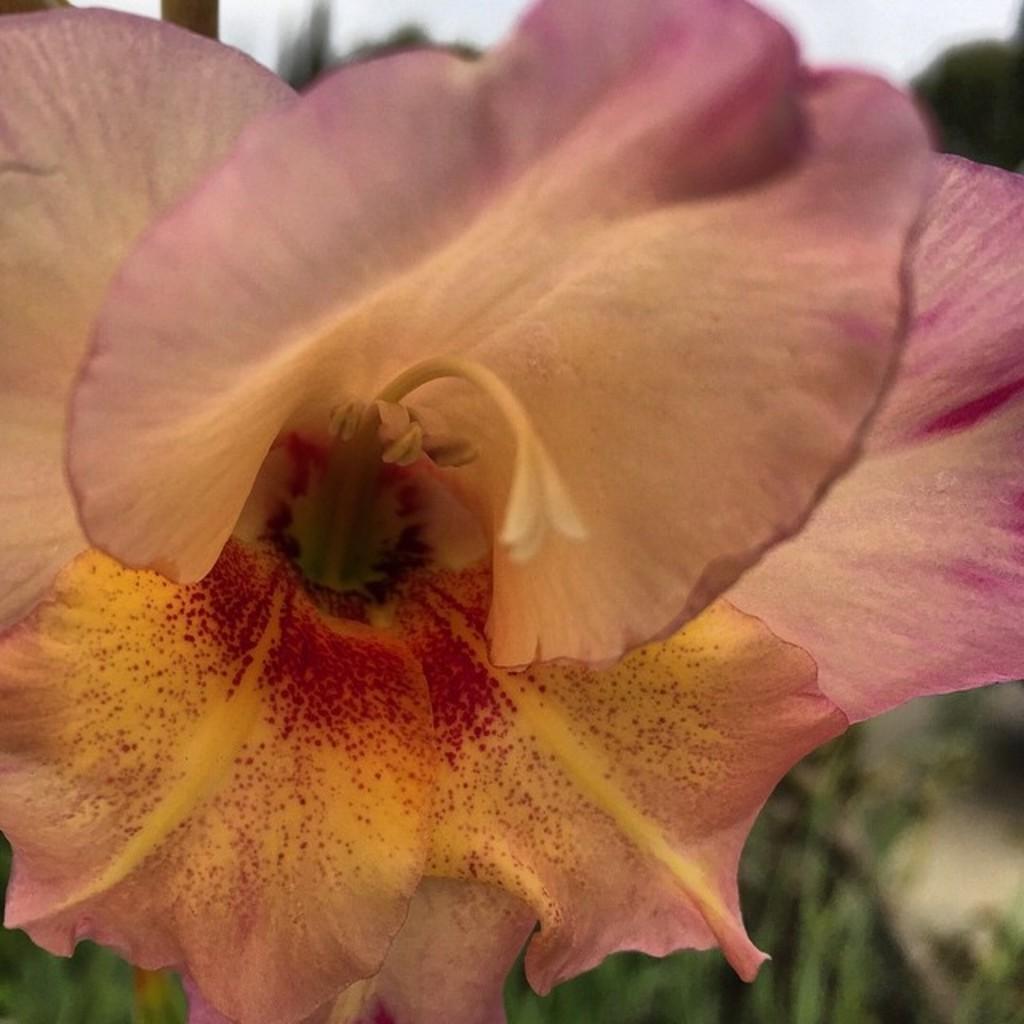Could you give a brief overview of what you see in this image? In this picture I can see a flower and a sky and I can see blurry background. 